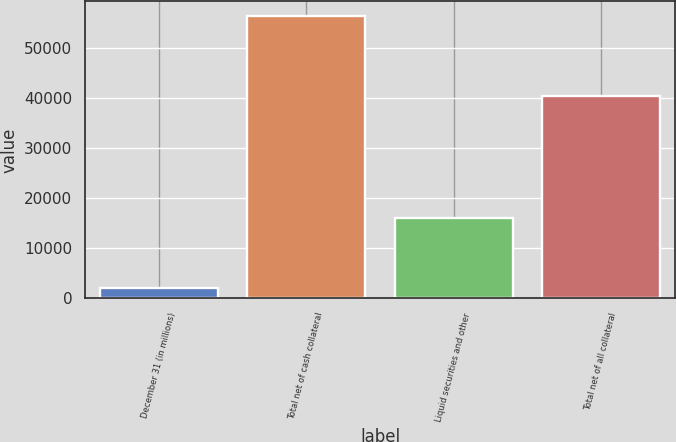Convert chart. <chart><loc_0><loc_0><loc_500><loc_500><bar_chart><fcel>December 31 (in millions)<fcel>Total net of cash collateral<fcel>Liquid securities and other<fcel>Total net of all collateral<nl><fcel>2017<fcel>56523<fcel>16108<fcel>40415<nl></chart> 